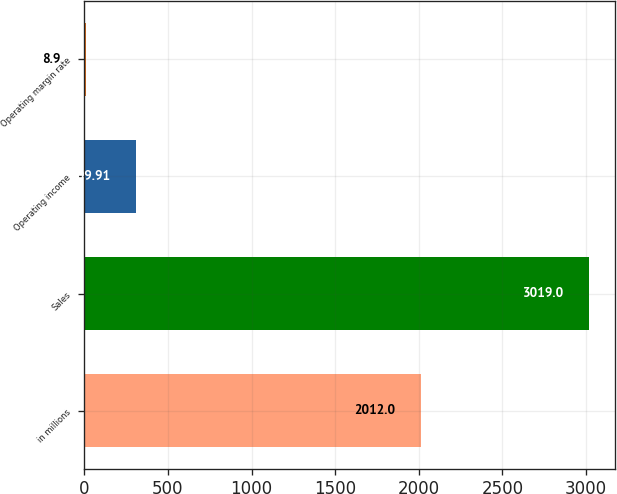Convert chart to OTSL. <chart><loc_0><loc_0><loc_500><loc_500><bar_chart><fcel>in millions<fcel>Sales<fcel>Operating income<fcel>Operating margin rate<nl><fcel>2012<fcel>3019<fcel>309.91<fcel>8.9<nl></chart> 